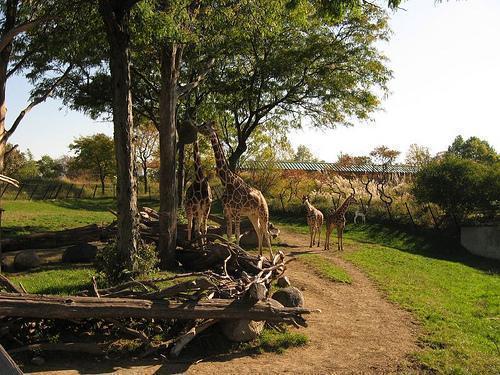Protected areas for these types of animals are known as what?
Select the accurate response from the four choices given to answer the question.
Options: States, wildlife reserves, demilitarized zones, unions. Wildlife reserves. 